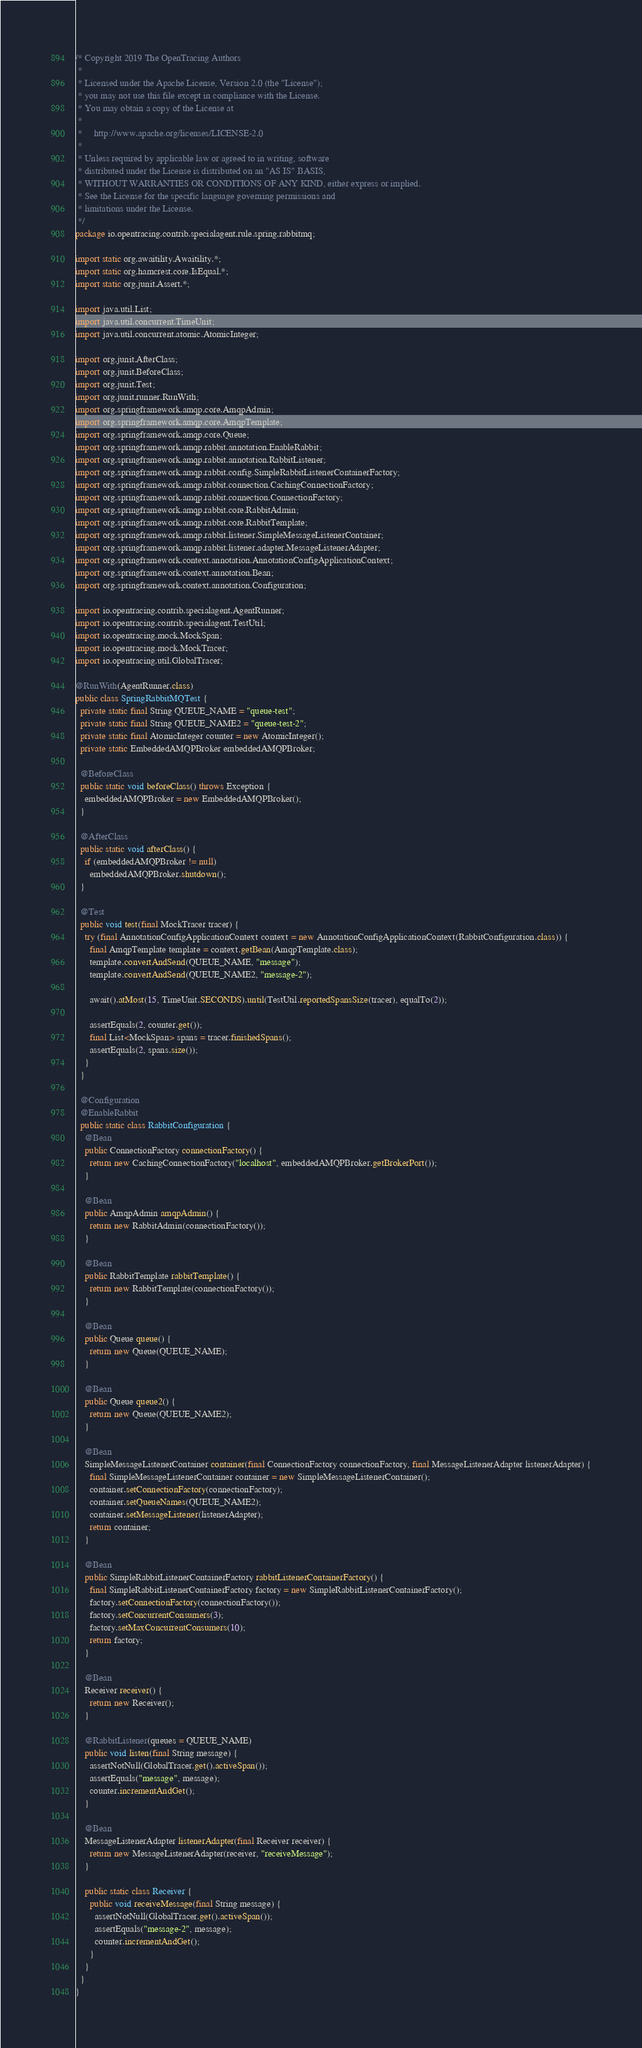Convert code to text. <code><loc_0><loc_0><loc_500><loc_500><_Java_>/* Copyright 2019 The OpenTracing Authors
 *
 * Licensed under the Apache License, Version 2.0 (the "License");
 * you may not use this file except in compliance with the License.
 * You may obtain a copy of the License at
 *
 *     http://www.apache.org/licenses/LICENSE-2.0
 *
 * Unless required by applicable law or agreed to in writing, software
 * distributed under the License is distributed on an "AS IS" BASIS,
 * WITHOUT WARRANTIES OR CONDITIONS OF ANY KIND, either express or implied.
 * See the License for the specific language governing permissions and
 * limitations under the License.
 */
package io.opentracing.contrib.specialagent.rule.spring.rabbitmq;

import static org.awaitility.Awaitility.*;
import static org.hamcrest.core.IsEqual.*;
import static org.junit.Assert.*;

import java.util.List;
import java.util.concurrent.TimeUnit;
import java.util.concurrent.atomic.AtomicInteger;

import org.junit.AfterClass;
import org.junit.BeforeClass;
import org.junit.Test;
import org.junit.runner.RunWith;
import org.springframework.amqp.core.AmqpAdmin;
import org.springframework.amqp.core.AmqpTemplate;
import org.springframework.amqp.core.Queue;
import org.springframework.amqp.rabbit.annotation.EnableRabbit;
import org.springframework.amqp.rabbit.annotation.RabbitListener;
import org.springframework.amqp.rabbit.config.SimpleRabbitListenerContainerFactory;
import org.springframework.amqp.rabbit.connection.CachingConnectionFactory;
import org.springframework.amqp.rabbit.connection.ConnectionFactory;
import org.springframework.amqp.rabbit.core.RabbitAdmin;
import org.springframework.amqp.rabbit.core.RabbitTemplate;
import org.springframework.amqp.rabbit.listener.SimpleMessageListenerContainer;
import org.springframework.amqp.rabbit.listener.adapter.MessageListenerAdapter;
import org.springframework.context.annotation.AnnotationConfigApplicationContext;
import org.springframework.context.annotation.Bean;
import org.springframework.context.annotation.Configuration;

import io.opentracing.contrib.specialagent.AgentRunner;
import io.opentracing.contrib.specialagent.TestUtil;
import io.opentracing.mock.MockSpan;
import io.opentracing.mock.MockTracer;
import io.opentracing.util.GlobalTracer;

@RunWith(AgentRunner.class)
public class SpringRabbitMQTest {
  private static final String QUEUE_NAME = "queue-test";
  private static final String QUEUE_NAME2 = "queue-test-2";
  private static final AtomicInteger counter = new AtomicInteger();
  private static EmbeddedAMQPBroker embeddedAMQPBroker;

  @BeforeClass
  public static void beforeClass() throws Exception {
    embeddedAMQPBroker = new EmbeddedAMQPBroker();
  }

  @AfterClass
  public static void afterClass() {
    if (embeddedAMQPBroker != null)
      embeddedAMQPBroker.shutdown();
  }

  @Test
  public void test(final MockTracer tracer) {
    try (final AnnotationConfigApplicationContext context = new AnnotationConfigApplicationContext(RabbitConfiguration.class)) {
      final AmqpTemplate template = context.getBean(AmqpTemplate.class);
      template.convertAndSend(QUEUE_NAME, "message");
      template.convertAndSend(QUEUE_NAME2, "message-2");

      await().atMost(15, TimeUnit.SECONDS).until(TestUtil.reportedSpansSize(tracer), equalTo(2));

      assertEquals(2, counter.get());
      final List<MockSpan> spans = tracer.finishedSpans();
      assertEquals(2, spans.size());
    }
  }

  @Configuration
  @EnableRabbit
  public static class RabbitConfiguration {
    @Bean
    public ConnectionFactory connectionFactory() {
      return new CachingConnectionFactory("localhost", embeddedAMQPBroker.getBrokerPort());
    }

    @Bean
    public AmqpAdmin amqpAdmin() {
      return new RabbitAdmin(connectionFactory());
    }

    @Bean
    public RabbitTemplate rabbitTemplate() {
      return new RabbitTemplate(connectionFactory());
    }

    @Bean
    public Queue queue() {
      return new Queue(QUEUE_NAME);
    }

    @Bean
    public Queue queue2() {
      return new Queue(QUEUE_NAME2);
    }

    @Bean
    SimpleMessageListenerContainer container(final ConnectionFactory connectionFactory, final MessageListenerAdapter listenerAdapter) {
      final SimpleMessageListenerContainer container = new SimpleMessageListenerContainer();
      container.setConnectionFactory(connectionFactory);
      container.setQueueNames(QUEUE_NAME2);
      container.setMessageListener(listenerAdapter);
      return container;
    }

    @Bean
    public SimpleRabbitListenerContainerFactory rabbitListenerContainerFactory() {
      final SimpleRabbitListenerContainerFactory factory = new SimpleRabbitListenerContainerFactory();
      factory.setConnectionFactory(connectionFactory());
      factory.setConcurrentConsumers(3);
      factory.setMaxConcurrentConsumers(10);
      return factory;
    }

    @Bean
    Receiver receiver() {
      return new Receiver();
    }

    @RabbitListener(queues = QUEUE_NAME)
    public void listen(final String message) {
      assertNotNull(GlobalTracer.get().activeSpan());
      assertEquals("message", message);
      counter.incrementAndGet();
    }

    @Bean
    MessageListenerAdapter listenerAdapter(final Receiver receiver) {
      return new MessageListenerAdapter(receiver, "receiveMessage");
    }

    public static class Receiver {
      public void receiveMessage(final String message) {
        assertNotNull(GlobalTracer.get().activeSpan());
        assertEquals("message-2", message);
        counter.incrementAndGet();
      }
    }
  }
}</code> 